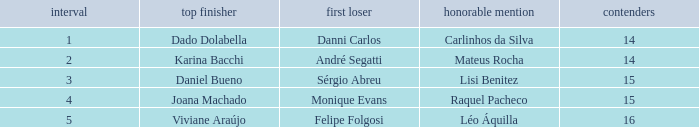In what season did Raquel Pacheco finish in third place? 4.0. 